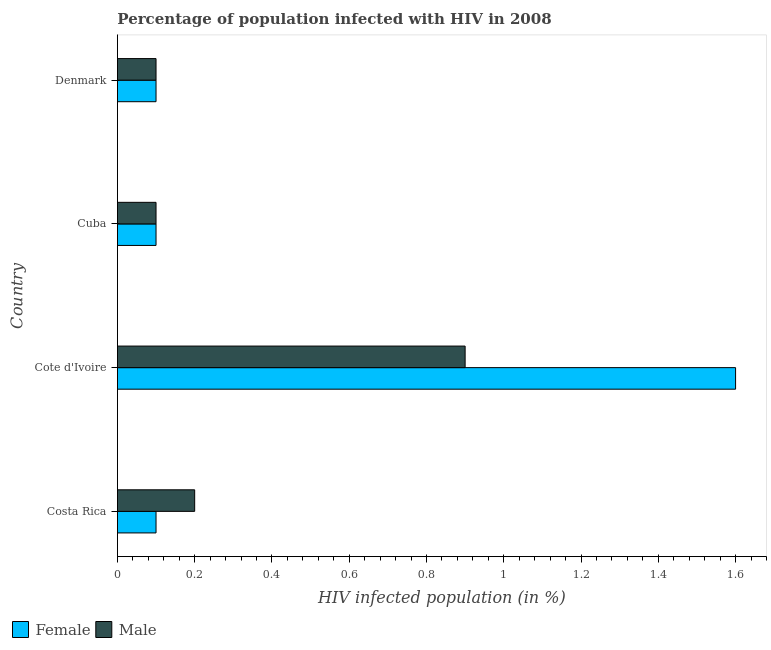Are the number of bars on each tick of the Y-axis equal?
Ensure brevity in your answer.  Yes. How many bars are there on the 2nd tick from the bottom?
Give a very brief answer. 2. Across all countries, what is the maximum percentage of females who are infected with hiv?
Ensure brevity in your answer.  1.6. In which country was the percentage of males who are infected with hiv maximum?
Your response must be concise. Cote d'Ivoire. In which country was the percentage of females who are infected with hiv minimum?
Offer a very short reply. Costa Rica. What is the total percentage of females who are infected with hiv in the graph?
Keep it short and to the point. 1.9. What is the difference between the percentage of males who are infected with hiv in Cote d'Ivoire and that in Denmark?
Your response must be concise. 0.8. What is the difference between the percentage of females who are infected with hiv in Costa Rica and the percentage of males who are infected with hiv in Cuba?
Make the answer very short. 0. What is the average percentage of males who are infected with hiv per country?
Provide a short and direct response. 0.33. What is the ratio of the percentage of females who are infected with hiv in Costa Rica to that in Cote d'Ivoire?
Provide a short and direct response. 0.06. What is the difference between the highest and the second highest percentage of females who are infected with hiv?
Provide a succinct answer. 1.5. What is the difference between the highest and the lowest percentage of females who are infected with hiv?
Offer a very short reply. 1.5. Is the sum of the percentage of males who are infected with hiv in Costa Rica and Cote d'Ivoire greater than the maximum percentage of females who are infected with hiv across all countries?
Ensure brevity in your answer.  No. What does the 2nd bar from the top in Denmark represents?
Your response must be concise. Female. What does the 1st bar from the bottom in Cuba represents?
Provide a succinct answer. Female. How many bars are there?
Keep it short and to the point. 8. What is the difference between two consecutive major ticks on the X-axis?
Offer a very short reply. 0.2. What is the title of the graph?
Offer a terse response. Percentage of population infected with HIV in 2008. What is the label or title of the X-axis?
Make the answer very short. HIV infected population (in %). What is the label or title of the Y-axis?
Offer a terse response. Country. What is the HIV infected population (in %) in Female in Costa Rica?
Provide a succinct answer. 0.1. What is the HIV infected population (in %) in Male in Costa Rica?
Your answer should be very brief. 0.2. What is the HIV infected population (in %) of Female in Cote d'Ivoire?
Offer a very short reply. 1.6. What is the HIV infected population (in %) in Female in Denmark?
Offer a very short reply. 0.1. What is the HIV infected population (in %) of Male in Denmark?
Provide a short and direct response. 0.1. Across all countries, what is the maximum HIV infected population (in %) of Female?
Make the answer very short. 1.6. Across all countries, what is the maximum HIV infected population (in %) of Male?
Ensure brevity in your answer.  0.9. Across all countries, what is the minimum HIV infected population (in %) in Female?
Your response must be concise. 0.1. Across all countries, what is the minimum HIV infected population (in %) of Male?
Provide a short and direct response. 0.1. What is the total HIV infected population (in %) in Male in the graph?
Ensure brevity in your answer.  1.3. What is the difference between the HIV infected population (in %) of Female in Costa Rica and that in Cote d'Ivoire?
Ensure brevity in your answer.  -1.5. What is the difference between the HIV infected population (in %) of Male in Costa Rica and that in Cuba?
Provide a short and direct response. 0.1. What is the difference between the HIV infected population (in %) in Female in Cote d'Ivoire and that in Denmark?
Ensure brevity in your answer.  1.5. What is the difference between the HIV infected population (in %) in Male in Cote d'Ivoire and that in Denmark?
Make the answer very short. 0.8. What is the difference between the HIV infected population (in %) in Female in Costa Rica and the HIV infected population (in %) in Male in Denmark?
Offer a very short reply. 0. What is the difference between the HIV infected population (in %) of Female in Cote d'Ivoire and the HIV infected population (in %) of Male in Cuba?
Your answer should be very brief. 1.5. What is the average HIV infected population (in %) in Female per country?
Provide a succinct answer. 0.47. What is the average HIV infected population (in %) in Male per country?
Give a very brief answer. 0.33. What is the difference between the HIV infected population (in %) of Female and HIV infected population (in %) of Male in Cote d'Ivoire?
Your answer should be compact. 0.7. What is the difference between the HIV infected population (in %) in Female and HIV infected population (in %) in Male in Denmark?
Keep it short and to the point. 0. What is the ratio of the HIV infected population (in %) of Female in Costa Rica to that in Cote d'Ivoire?
Provide a short and direct response. 0.06. What is the ratio of the HIV infected population (in %) of Male in Costa Rica to that in Cote d'Ivoire?
Keep it short and to the point. 0.22. What is the ratio of the HIV infected population (in %) of Female in Costa Rica to that in Cuba?
Keep it short and to the point. 1. What is the ratio of the HIV infected population (in %) in Male in Costa Rica to that in Cuba?
Provide a short and direct response. 2. What is the ratio of the HIV infected population (in %) in Female in Cote d'Ivoire to that in Cuba?
Make the answer very short. 16. What is the ratio of the HIV infected population (in %) in Male in Cote d'Ivoire to that in Cuba?
Offer a terse response. 9. What is the ratio of the HIV infected population (in %) of Male in Cote d'Ivoire to that in Denmark?
Offer a very short reply. 9. What is the difference between the highest and the second highest HIV infected population (in %) in Female?
Give a very brief answer. 1.5. What is the difference between the highest and the second highest HIV infected population (in %) in Male?
Keep it short and to the point. 0.7. What is the difference between the highest and the lowest HIV infected population (in %) of Male?
Your response must be concise. 0.8. 